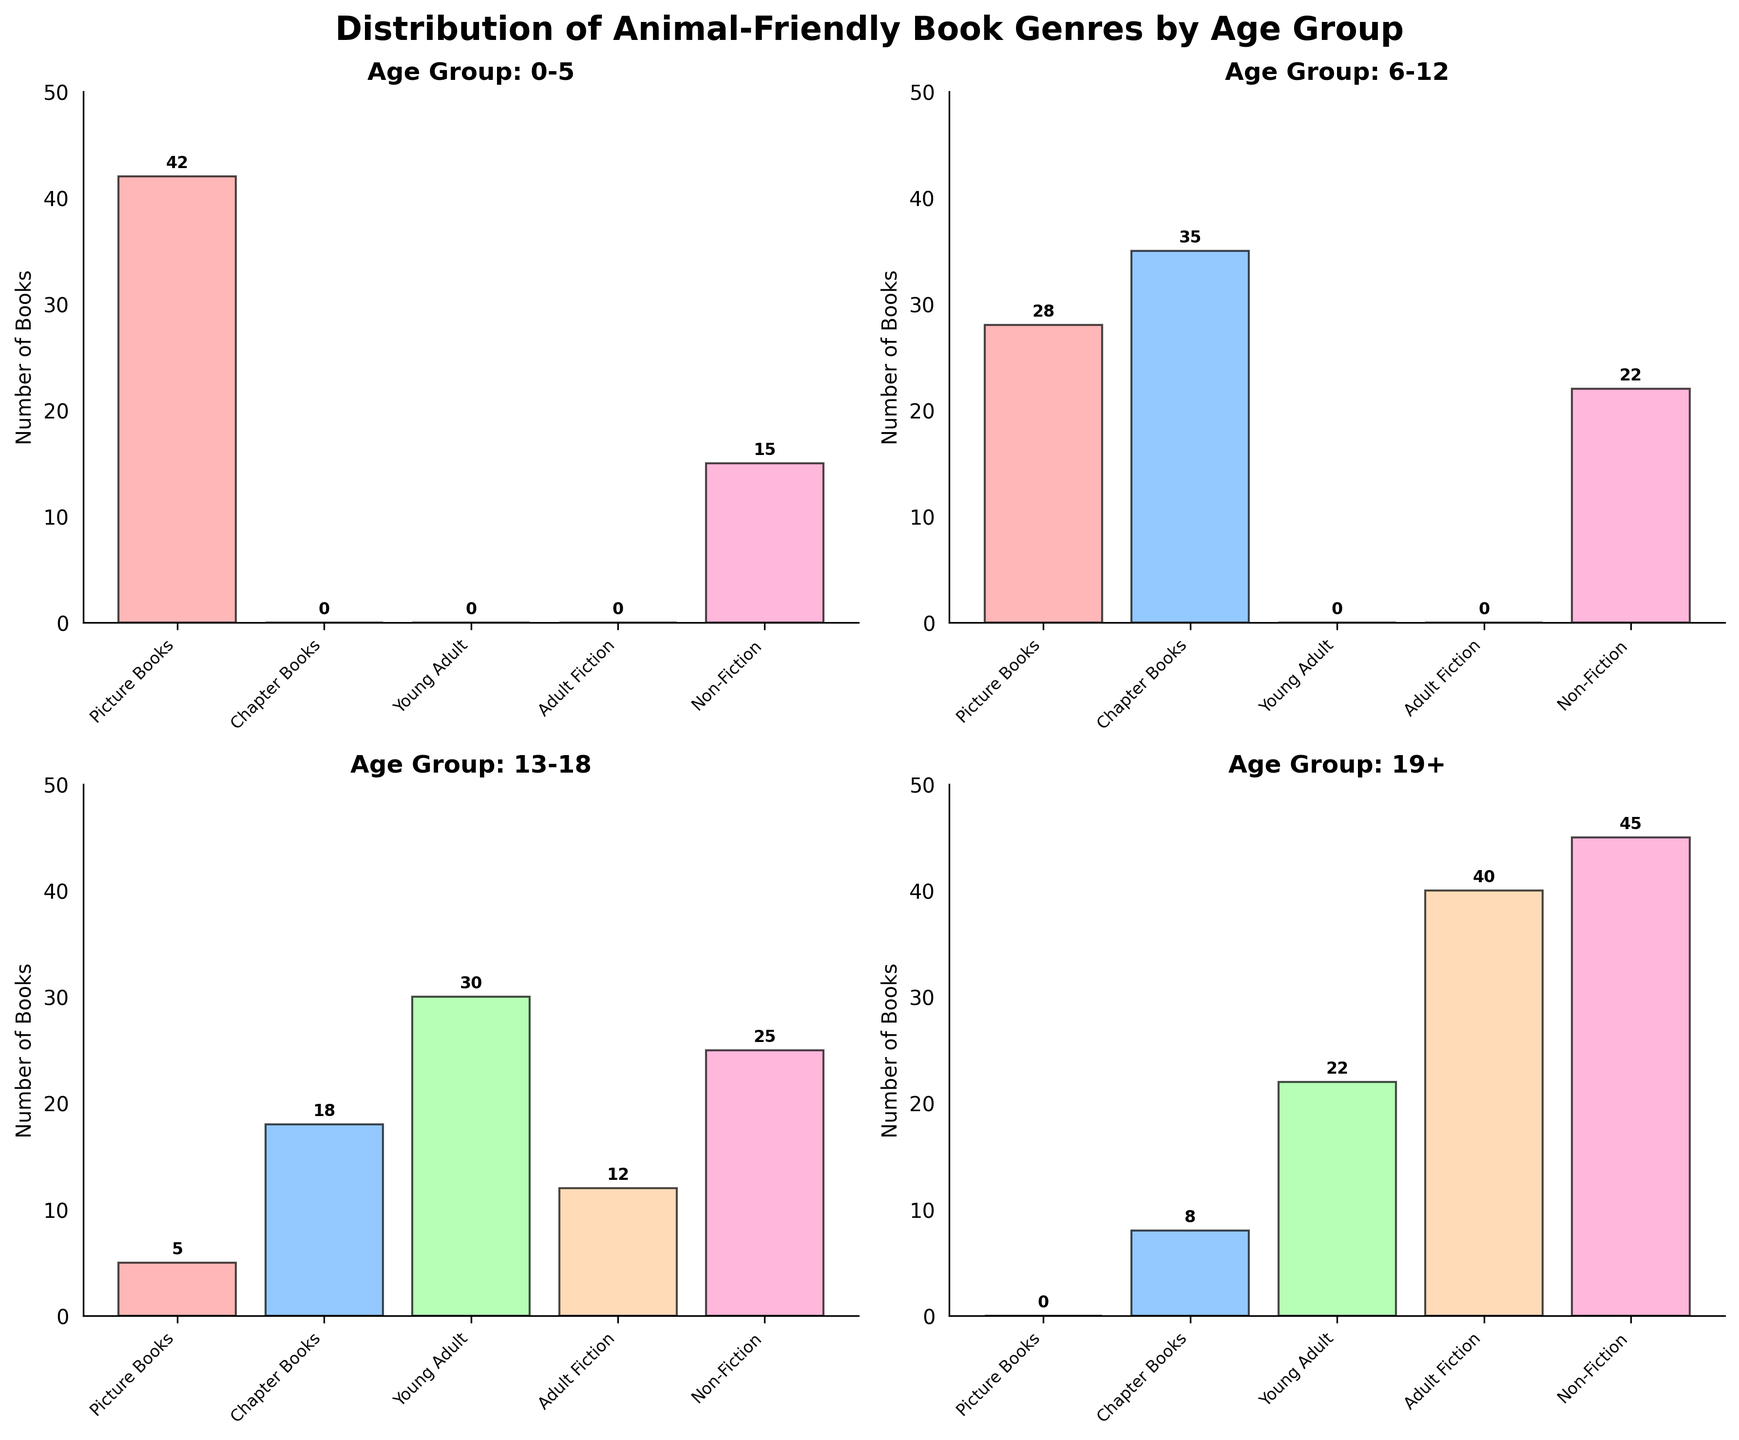What is the title of the figure? The title is typically displayed at the top of the figure in larger, bold font. The title helps to quickly understand the purpose or topic of the figure.
Answer: Distribution of Animal-Friendly Book Genres by Age Group How many subplots are there in the figure? A subplot is a smaller plot that is part of a larger figure. The number of subplots can be counted visually as separate sections within the figure.
Answer: 4 Which age group has the highest number of books in the Picture Books genre? Look at the bar heights for the Picture Books genre across all age groups. The highest bar represents the age group with the most Picture Books.
Answer: 0-5 For the age group 6-12, how many more Chapter Books are there compared to Picture Books? First, identify the number of Chapter Books and Picture Books for the age group 6-12. Then, subtract the number of Picture Books from the number of Chapter Books.
Answer: 7 Which genre is most prevalent for the age group 19+? Check the heights of the bars for each genre in the 19+ age group. The tallest bar indicates the most prevalent genre.
Answer: Non-Fiction How does the number of Non-Fiction books compare between age groups 13-18 and 19+? Compare the heights of the Non-Fiction bars for age groups 13-18 and 19+. The taller bar indicates which age group has more Non-Fiction books.
Answer: Age group 19+ has more Calculate the total number of books for the age group 13-18. Add up the number of books across all genres for the age group 13-18.
Answer: 90 Which age group has no representation in the Adult Fiction genre? Identify the age groups and see where the bar for Adult Fiction genre is either absent or has a height of zero.
Answer: 0-5 and 6-12 What is the average number of books per genre in the age group 0-5? Sum the number of books across all genres for the age group 0-5 and divide by the number of genres. This will give the average number of books per genre.
Answer: 11.4 